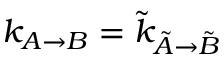Convert formula to latex. <formula><loc_0><loc_0><loc_500><loc_500>k _ { A \rightarrow B } = \tilde { k } _ { \tilde { A } \rightarrow \tilde { B } }</formula> 